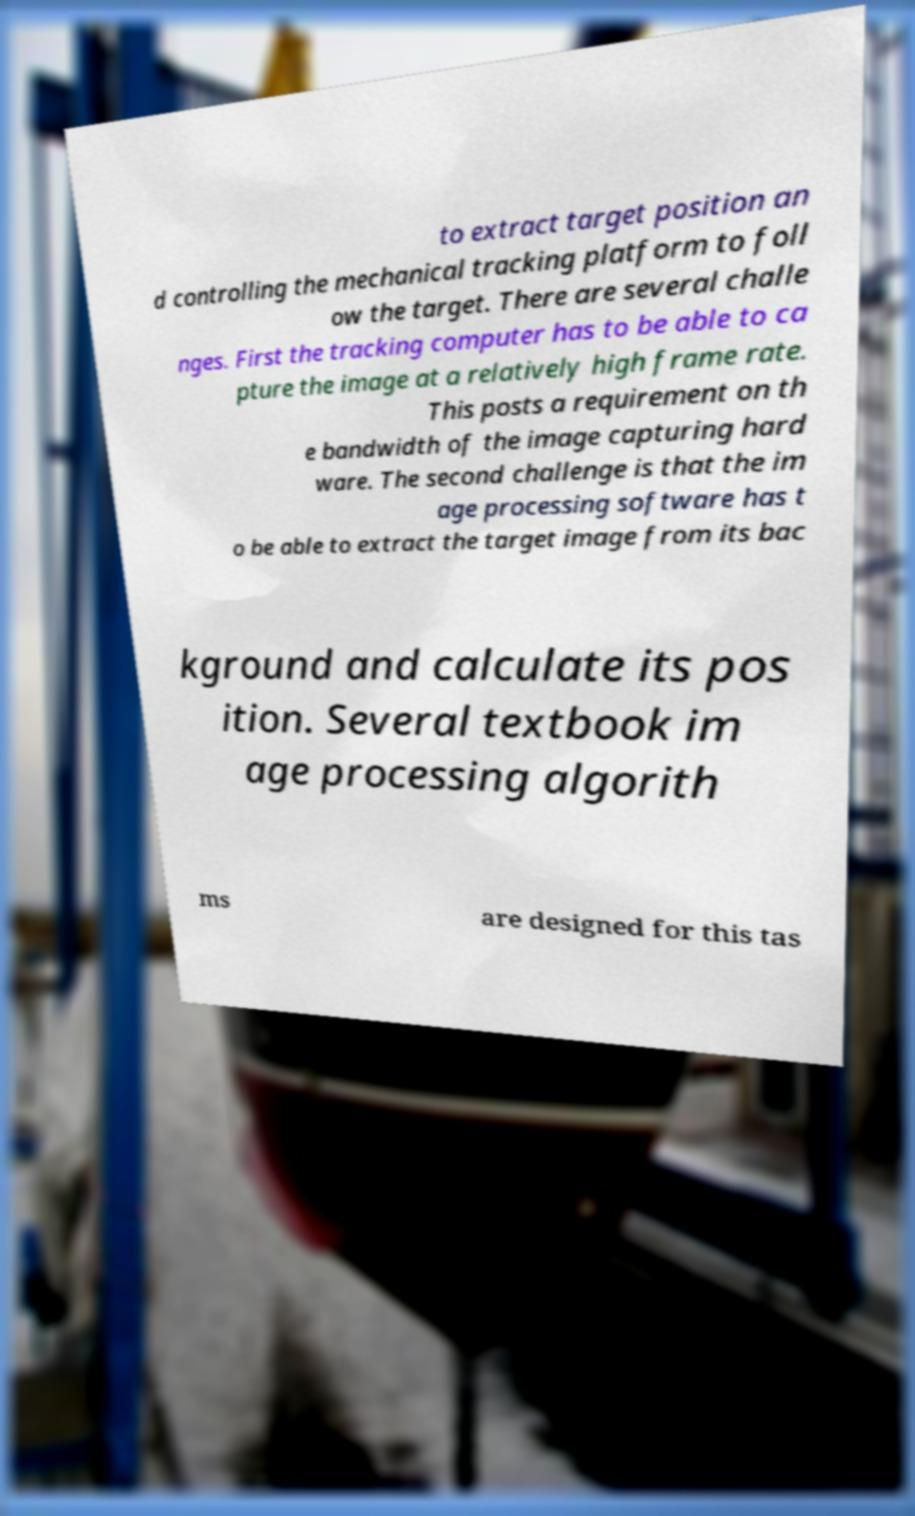Could you extract and type out the text from this image? to extract target position an d controlling the mechanical tracking platform to foll ow the target. There are several challe nges. First the tracking computer has to be able to ca pture the image at a relatively high frame rate. This posts a requirement on th e bandwidth of the image capturing hard ware. The second challenge is that the im age processing software has t o be able to extract the target image from its bac kground and calculate its pos ition. Several textbook im age processing algorith ms are designed for this tas 